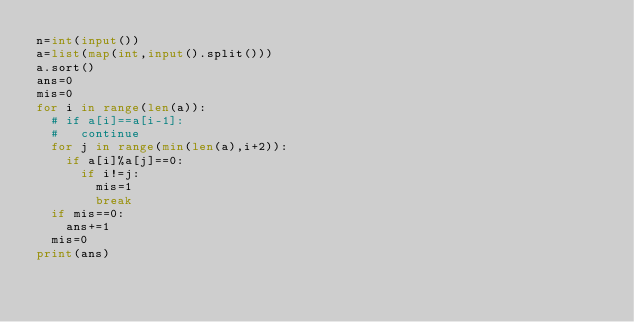Convert code to text. <code><loc_0><loc_0><loc_500><loc_500><_Python_>n=int(input())
a=list(map(int,input().split()))
a.sort()
ans=0
mis=0
for i in range(len(a)):
  # if a[i]==a[i-1]:
  #   continue
  for j in range(min(len(a),i+2)):
    if a[i]%a[j]==0:
      if i!=j:
        mis=1
        break
  if mis==0:
    ans+=1
  mis=0
print(ans)
</code> 